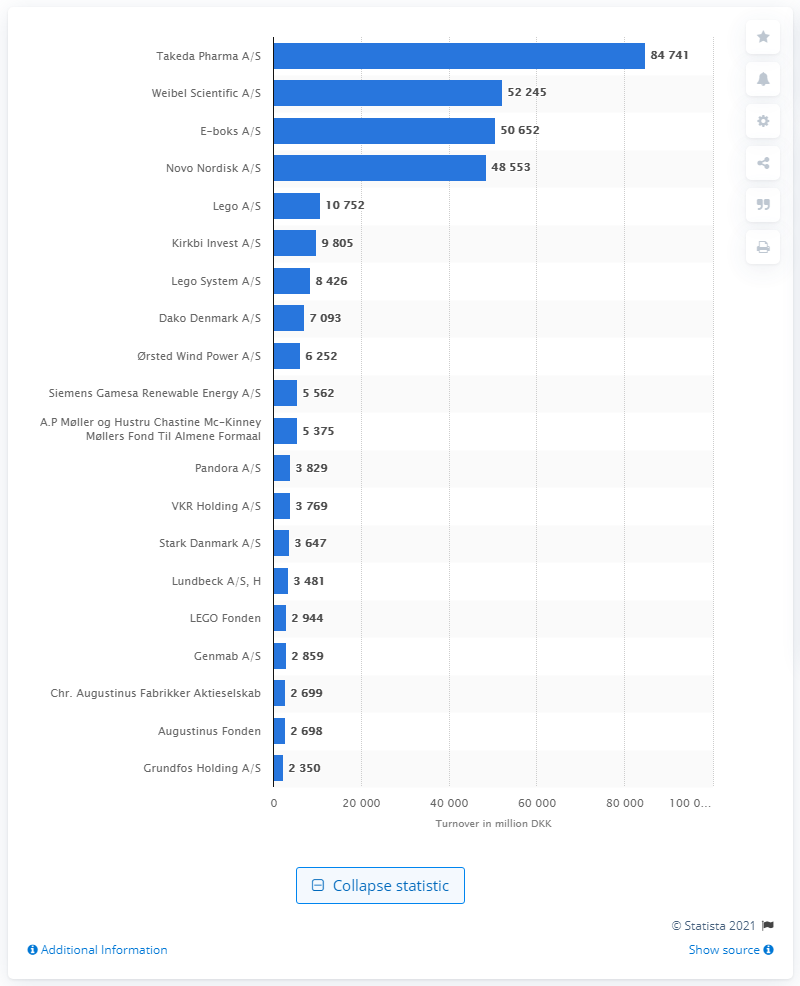Specify some key components in this picture. The toy production company in Denmark is named Lego A/S. Takeda Pharma A/S's net profit in Danish kroner was 84,741. 